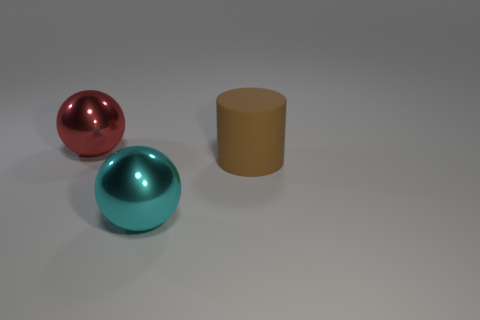Subtract all cyan spheres. How many spheres are left? 1 Subtract all blue balls. Subtract all yellow cylinders. How many balls are left? 2 Subtract all purple cubes. How many yellow cylinders are left? 0 Subtract 1 brown cylinders. How many objects are left? 2 Subtract all cylinders. How many objects are left? 2 Subtract 1 cylinders. How many cylinders are left? 0 Subtract all large brown matte things. Subtract all cyan balls. How many objects are left? 1 Add 1 big cyan things. How many big cyan things are left? 2 Add 3 red cylinders. How many red cylinders exist? 3 Add 1 matte cylinders. How many objects exist? 4 